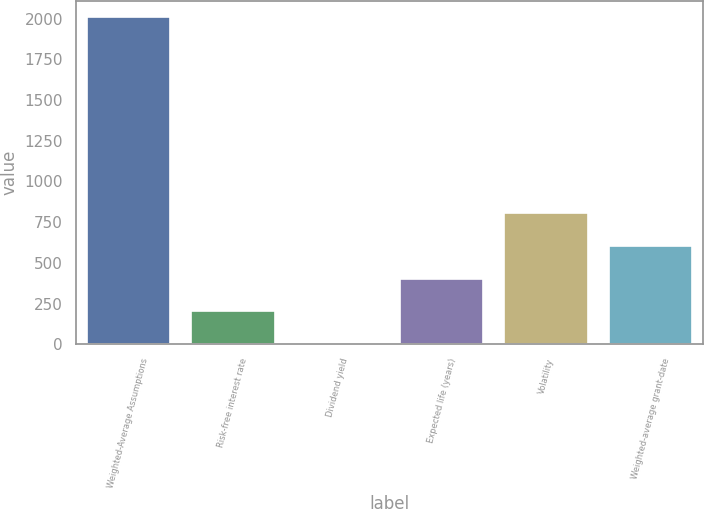Convert chart to OTSL. <chart><loc_0><loc_0><loc_500><loc_500><bar_chart><fcel>Weighted-Average Assumptions<fcel>Risk-free interest rate<fcel>Dividend yield<fcel>Expected life (years)<fcel>Volatility<fcel>Weighted-average grant-date<nl><fcel>2010<fcel>202.62<fcel>1.8<fcel>403.44<fcel>805.08<fcel>604.26<nl></chart> 